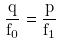Convert formula to latex. <formula><loc_0><loc_0><loc_500><loc_500>\frac { q } { f _ { 0 } } = \frac { p } { f _ { 1 } }</formula> 